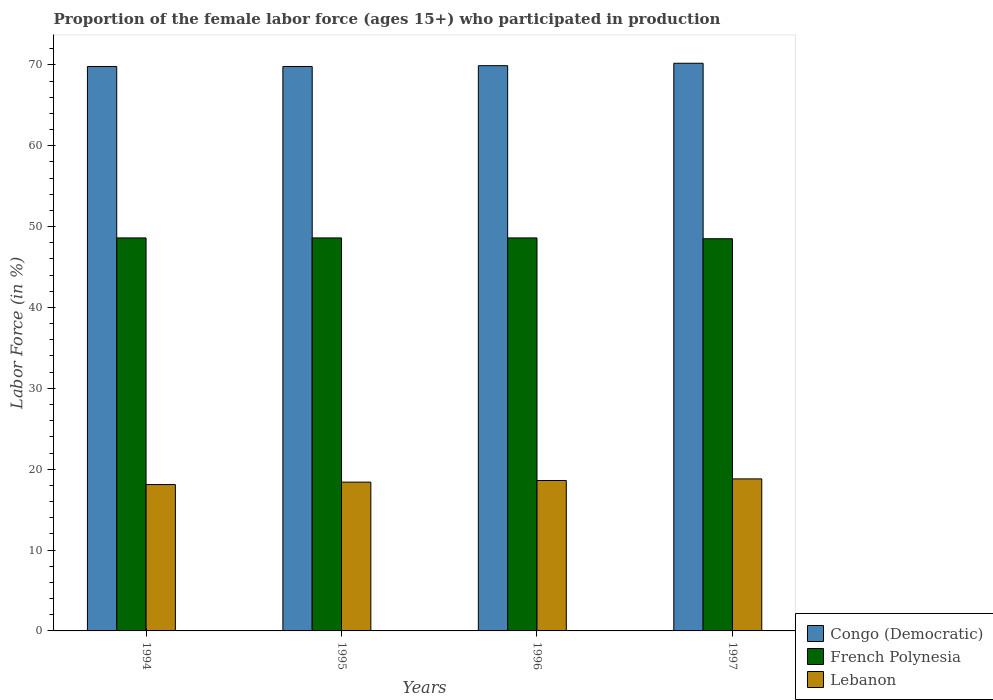Are the number of bars per tick equal to the number of legend labels?
Your answer should be very brief. Yes. How many bars are there on the 1st tick from the left?
Your response must be concise. 3. In how many cases, is the number of bars for a given year not equal to the number of legend labels?
Give a very brief answer. 0. What is the proportion of the female labor force who participated in production in Congo (Democratic) in 1997?
Your response must be concise. 70.2. Across all years, what is the maximum proportion of the female labor force who participated in production in Lebanon?
Offer a very short reply. 18.8. Across all years, what is the minimum proportion of the female labor force who participated in production in Congo (Democratic)?
Keep it short and to the point. 69.8. In which year was the proportion of the female labor force who participated in production in Congo (Democratic) maximum?
Provide a short and direct response. 1997. What is the total proportion of the female labor force who participated in production in Lebanon in the graph?
Provide a succinct answer. 73.9. What is the difference between the proportion of the female labor force who participated in production in Congo (Democratic) in 1994 and that in 1997?
Keep it short and to the point. -0.4. What is the difference between the proportion of the female labor force who participated in production in Congo (Democratic) in 1996 and the proportion of the female labor force who participated in production in Lebanon in 1994?
Your answer should be compact. 51.8. What is the average proportion of the female labor force who participated in production in Lebanon per year?
Your answer should be very brief. 18.47. In the year 1995, what is the difference between the proportion of the female labor force who participated in production in Congo (Democratic) and proportion of the female labor force who participated in production in French Polynesia?
Your answer should be compact. 21.2. What is the ratio of the proportion of the female labor force who participated in production in Congo (Democratic) in 1996 to that in 1997?
Offer a terse response. 1. What is the difference between the highest and the second highest proportion of the female labor force who participated in production in Congo (Democratic)?
Make the answer very short. 0.3. What is the difference between the highest and the lowest proportion of the female labor force who participated in production in Congo (Democratic)?
Give a very brief answer. 0.4. Is the sum of the proportion of the female labor force who participated in production in Congo (Democratic) in 1994 and 1996 greater than the maximum proportion of the female labor force who participated in production in French Polynesia across all years?
Make the answer very short. Yes. What does the 3rd bar from the left in 1996 represents?
Give a very brief answer. Lebanon. What does the 2nd bar from the right in 1995 represents?
Offer a very short reply. French Polynesia. Are all the bars in the graph horizontal?
Offer a very short reply. No. How many years are there in the graph?
Ensure brevity in your answer.  4. What is the difference between two consecutive major ticks on the Y-axis?
Offer a very short reply. 10. Are the values on the major ticks of Y-axis written in scientific E-notation?
Keep it short and to the point. No. Where does the legend appear in the graph?
Provide a succinct answer. Bottom right. How many legend labels are there?
Your answer should be compact. 3. How are the legend labels stacked?
Your answer should be very brief. Vertical. What is the title of the graph?
Your response must be concise. Proportion of the female labor force (ages 15+) who participated in production. What is the label or title of the Y-axis?
Your answer should be very brief. Labor Force (in %). What is the Labor Force (in %) in Congo (Democratic) in 1994?
Make the answer very short. 69.8. What is the Labor Force (in %) in French Polynesia in 1994?
Ensure brevity in your answer.  48.6. What is the Labor Force (in %) of Lebanon in 1994?
Give a very brief answer. 18.1. What is the Labor Force (in %) in Congo (Democratic) in 1995?
Ensure brevity in your answer.  69.8. What is the Labor Force (in %) in French Polynesia in 1995?
Give a very brief answer. 48.6. What is the Labor Force (in %) in Lebanon in 1995?
Your answer should be very brief. 18.4. What is the Labor Force (in %) in Congo (Democratic) in 1996?
Your answer should be very brief. 69.9. What is the Labor Force (in %) of French Polynesia in 1996?
Ensure brevity in your answer.  48.6. What is the Labor Force (in %) in Lebanon in 1996?
Provide a succinct answer. 18.6. What is the Labor Force (in %) of Congo (Democratic) in 1997?
Your answer should be compact. 70.2. What is the Labor Force (in %) in French Polynesia in 1997?
Ensure brevity in your answer.  48.5. What is the Labor Force (in %) of Lebanon in 1997?
Your answer should be compact. 18.8. Across all years, what is the maximum Labor Force (in %) in Congo (Democratic)?
Offer a very short reply. 70.2. Across all years, what is the maximum Labor Force (in %) in French Polynesia?
Your response must be concise. 48.6. Across all years, what is the maximum Labor Force (in %) of Lebanon?
Your response must be concise. 18.8. Across all years, what is the minimum Labor Force (in %) of Congo (Democratic)?
Offer a very short reply. 69.8. Across all years, what is the minimum Labor Force (in %) of French Polynesia?
Your answer should be compact. 48.5. Across all years, what is the minimum Labor Force (in %) of Lebanon?
Provide a succinct answer. 18.1. What is the total Labor Force (in %) in Congo (Democratic) in the graph?
Your response must be concise. 279.7. What is the total Labor Force (in %) in French Polynesia in the graph?
Provide a succinct answer. 194.3. What is the total Labor Force (in %) of Lebanon in the graph?
Offer a terse response. 73.9. What is the difference between the Labor Force (in %) of Congo (Democratic) in 1994 and that in 1995?
Provide a short and direct response. 0. What is the difference between the Labor Force (in %) of Lebanon in 1994 and that in 1995?
Your answer should be compact. -0.3. What is the difference between the Labor Force (in %) in Congo (Democratic) in 1994 and that in 1996?
Provide a succinct answer. -0.1. What is the difference between the Labor Force (in %) in French Polynesia in 1994 and that in 1997?
Give a very brief answer. 0.1. What is the difference between the Labor Force (in %) in Lebanon in 1994 and that in 1997?
Provide a short and direct response. -0.7. What is the difference between the Labor Force (in %) in Lebanon in 1995 and that in 1996?
Give a very brief answer. -0.2. What is the difference between the Labor Force (in %) of Congo (Democratic) in 1996 and that in 1997?
Your answer should be compact. -0.3. What is the difference between the Labor Force (in %) of Lebanon in 1996 and that in 1997?
Give a very brief answer. -0.2. What is the difference between the Labor Force (in %) in Congo (Democratic) in 1994 and the Labor Force (in %) in French Polynesia in 1995?
Give a very brief answer. 21.2. What is the difference between the Labor Force (in %) in Congo (Democratic) in 1994 and the Labor Force (in %) in Lebanon in 1995?
Provide a succinct answer. 51.4. What is the difference between the Labor Force (in %) in French Polynesia in 1994 and the Labor Force (in %) in Lebanon in 1995?
Give a very brief answer. 30.2. What is the difference between the Labor Force (in %) in Congo (Democratic) in 1994 and the Labor Force (in %) in French Polynesia in 1996?
Give a very brief answer. 21.2. What is the difference between the Labor Force (in %) in Congo (Democratic) in 1994 and the Labor Force (in %) in Lebanon in 1996?
Your answer should be very brief. 51.2. What is the difference between the Labor Force (in %) of Congo (Democratic) in 1994 and the Labor Force (in %) of French Polynesia in 1997?
Give a very brief answer. 21.3. What is the difference between the Labor Force (in %) of French Polynesia in 1994 and the Labor Force (in %) of Lebanon in 1997?
Your response must be concise. 29.8. What is the difference between the Labor Force (in %) in Congo (Democratic) in 1995 and the Labor Force (in %) in French Polynesia in 1996?
Give a very brief answer. 21.2. What is the difference between the Labor Force (in %) of Congo (Democratic) in 1995 and the Labor Force (in %) of Lebanon in 1996?
Give a very brief answer. 51.2. What is the difference between the Labor Force (in %) of French Polynesia in 1995 and the Labor Force (in %) of Lebanon in 1996?
Ensure brevity in your answer.  30. What is the difference between the Labor Force (in %) in Congo (Democratic) in 1995 and the Labor Force (in %) in French Polynesia in 1997?
Ensure brevity in your answer.  21.3. What is the difference between the Labor Force (in %) in Congo (Democratic) in 1995 and the Labor Force (in %) in Lebanon in 1997?
Offer a terse response. 51. What is the difference between the Labor Force (in %) in French Polynesia in 1995 and the Labor Force (in %) in Lebanon in 1997?
Your response must be concise. 29.8. What is the difference between the Labor Force (in %) in Congo (Democratic) in 1996 and the Labor Force (in %) in French Polynesia in 1997?
Make the answer very short. 21.4. What is the difference between the Labor Force (in %) of Congo (Democratic) in 1996 and the Labor Force (in %) of Lebanon in 1997?
Provide a succinct answer. 51.1. What is the difference between the Labor Force (in %) of French Polynesia in 1996 and the Labor Force (in %) of Lebanon in 1997?
Make the answer very short. 29.8. What is the average Labor Force (in %) in Congo (Democratic) per year?
Provide a short and direct response. 69.92. What is the average Labor Force (in %) of French Polynesia per year?
Make the answer very short. 48.58. What is the average Labor Force (in %) of Lebanon per year?
Keep it short and to the point. 18.48. In the year 1994, what is the difference between the Labor Force (in %) of Congo (Democratic) and Labor Force (in %) of French Polynesia?
Your answer should be compact. 21.2. In the year 1994, what is the difference between the Labor Force (in %) of Congo (Democratic) and Labor Force (in %) of Lebanon?
Make the answer very short. 51.7. In the year 1994, what is the difference between the Labor Force (in %) of French Polynesia and Labor Force (in %) of Lebanon?
Make the answer very short. 30.5. In the year 1995, what is the difference between the Labor Force (in %) of Congo (Democratic) and Labor Force (in %) of French Polynesia?
Your answer should be compact. 21.2. In the year 1995, what is the difference between the Labor Force (in %) in Congo (Democratic) and Labor Force (in %) in Lebanon?
Your answer should be very brief. 51.4. In the year 1995, what is the difference between the Labor Force (in %) of French Polynesia and Labor Force (in %) of Lebanon?
Your answer should be compact. 30.2. In the year 1996, what is the difference between the Labor Force (in %) in Congo (Democratic) and Labor Force (in %) in French Polynesia?
Ensure brevity in your answer.  21.3. In the year 1996, what is the difference between the Labor Force (in %) of Congo (Democratic) and Labor Force (in %) of Lebanon?
Your answer should be compact. 51.3. In the year 1996, what is the difference between the Labor Force (in %) of French Polynesia and Labor Force (in %) of Lebanon?
Your answer should be compact. 30. In the year 1997, what is the difference between the Labor Force (in %) of Congo (Democratic) and Labor Force (in %) of French Polynesia?
Give a very brief answer. 21.7. In the year 1997, what is the difference between the Labor Force (in %) of Congo (Democratic) and Labor Force (in %) of Lebanon?
Provide a succinct answer. 51.4. In the year 1997, what is the difference between the Labor Force (in %) in French Polynesia and Labor Force (in %) in Lebanon?
Your response must be concise. 29.7. What is the ratio of the Labor Force (in %) of French Polynesia in 1994 to that in 1995?
Offer a very short reply. 1. What is the ratio of the Labor Force (in %) of Lebanon in 1994 to that in 1995?
Make the answer very short. 0.98. What is the ratio of the Labor Force (in %) of Congo (Democratic) in 1994 to that in 1996?
Provide a short and direct response. 1. What is the ratio of the Labor Force (in %) in French Polynesia in 1994 to that in 1996?
Your answer should be compact. 1. What is the ratio of the Labor Force (in %) in Lebanon in 1994 to that in 1996?
Keep it short and to the point. 0.97. What is the ratio of the Labor Force (in %) of Congo (Democratic) in 1994 to that in 1997?
Make the answer very short. 0.99. What is the ratio of the Labor Force (in %) in Lebanon in 1994 to that in 1997?
Ensure brevity in your answer.  0.96. What is the ratio of the Labor Force (in %) in Lebanon in 1995 to that in 1997?
Provide a short and direct response. 0.98. What is the ratio of the Labor Force (in %) in Congo (Democratic) in 1996 to that in 1997?
Give a very brief answer. 1. What is the ratio of the Labor Force (in %) of Lebanon in 1996 to that in 1997?
Your answer should be very brief. 0.99. What is the difference between the highest and the lowest Labor Force (in %) in French Polynesia?
Provide a short and direct response. 0.1. 